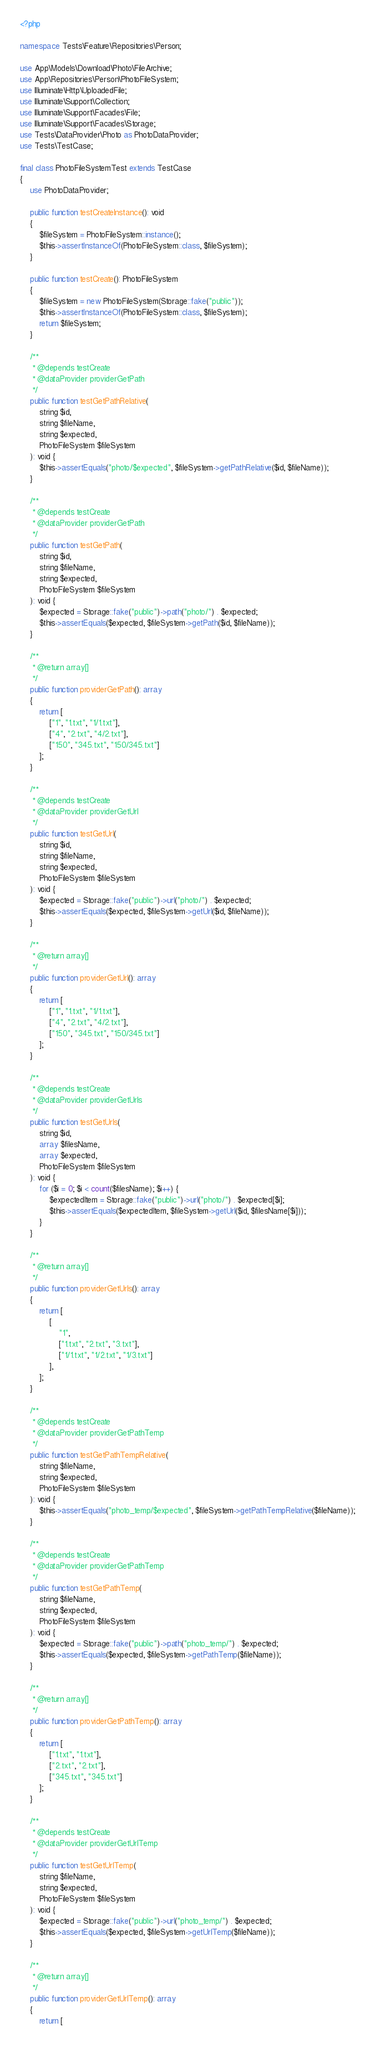<code> <loc_0><loc_0><loc_500><loc_500><_PHP_><?php

namespace Tests\Feature\Repositories\Person;

use App\Models\Download\Photo\FileArchive;
use App\Repositories\Person\PhotoFileSystem;
use Illuminate\Http\UploadedFile;
use Illuminate\Support\Collection;
use Illuminate\Support\Facades\File;
use Illuminate\Support\Facades\Storage;
use Tests\DataProvider\Photo as PhotoDataProvider;
use Tests\TestCase;

final class PhotoFileSystemTest extends TestCase
{
    use PhotoDataProvider;

    public function testCreateInstance(): void
    {
        $fileSystem = PhotoFileSystem::instance();
        $this->assertInstanceOf(PhotoFileSystem::class, $fileSystem);
    }

    public function testCreate(): PhotoFileSystem
    {
        $fileSystem = new PhotoFileSystem(Storage::fake("public"));
        $this->assertInstanceOf(PhotoFileSystem::class, $fileSystem);
        return $fileSystem;
    }

    /**
     * @depends testCreate
     * @dataProvider providerGetPath
     */
    public function testGetPathRelative(
        string $id,
        string $fileName,
        string $expected,
        PhotoFileSystem $fileSystem
    ): void {
        $this->assertEquals("photo/$expected", $fileSystem->getPathRelative($id, $fileName));
    }

    /**
     * @depends testCreate
     * @dataProvider providerGetPath
     */
    public function testGetPath(
        string $id,
        string $fileName,
        string $expected,
        PhotoFileSystem $fileSystem
    ): void {
        $expected = Storage::fake("public")->path("photo/") . $expected;
        $this->assertEquals($expected, $fileSystem->getPath($id, $fileName));
    }

    /**
     * @return array[]
     */
    public function providerGetPath(): array
    {
        return [
            ["1", "1.txt", "1/1.txt"],
            ["4", "2.txt", "4/2.txt"],
            ["150", "345.txt", "150/345.txt"]
        ];
    }

    /**
     * @depends testCreate
     * @dataProvider providerGetUrl
     */
    public function testGetUrl(
        string $id,
        string $fileName,
        string $expected,
        PhotoFileSystem $fileSystem
    ): void {
        $expected = Storage::fake("public")->url("photo/") . $expected;
        $this->assertEquals($expected, $fileSystem->getUrl($id, $fileName));
    }

    /**
     * @return array[]
     */
    public function providerGetUrl(): array
    {
        return [
            ["1", "1.txt", "1/1.txt"],
            ["4", "2.txt", "4/2.txt"],
            ["150", "345.txt", "150/345.txt"]
        ];
    }

    /**
     * @depends testCreate
     * @dataProvider providerGetUrls
     */
    public function testGetUrls(
        string $id,
        array $filesName,
        array $expected,
        PhotoFileSystem $fileSystem
    ): void {
        for ($i = 0; $i < count($filesName); $i++) {
            $expectedItem = Storage::fake("public")->url("photo/") . $expected[$i];
            $this->assertEquals($expectedItem, $fileSystem->getUrl($id, $filesName[$i]));
        }
    }

    /**
     * @return array[]
     */
    public function providerGetUrls(): array
    {
        return [
            [
                "1",
                ["1.txt", "2.txt", "3.txt"],
                ["1/1.txt", "1/2.txt", "1/3.txt"]
            ],
        ];
    }

    /**
     * @depends testCreate
     * @dataProvider providerGetPathTemp
     */
    public function testGetPathTempRelative(
        string $fileName,
        string $expected,
        PhotoFileSystem $fileSystem
    ): void {
        $this->assertEquals("photo_temp/$expected", $fileSystem->getPathTempRelative($fileName));
    }

    /**
     * @depends testCreate
     * @dataProvider providerGetPathTemp
     */
    public function testGetPathTemp(
        string $fileName,
        string $expected,
        PhotoFileSystem $fileSystem
    ): void {
        $expected = Storage::fake("public")->path("photo_temp/") . $expected;
        $this->assertEquals($expected, $fileSystem->getPathTemp($fileName));
    }

    /**
     * @return array[]
     */
    public function providerGetPathTemp(): array
    {
        return [
            ["1.txt", "1.txt"],
            ["2.txt", "2.txt"],
            ["345.txt", "345.txt"]
        ];
    }

    /**
     * @depends testCreate
     * @dataProvider providerGetUrlTemp
     */
    public function testGetUrlTemp(
        string $fileName,
        string $expected,
        PhotoFileSystem $fileSystem
    ): void {
        $expected = Storage::fake("public")->url("photo_temp/") . $expected;
        $this->assertEquals($expected, $fileSystem->getUrlTemp($fileName));
    }

    /**
     * @return array[]
     */
    public function providerGetUrlTemp(): array
    {
        return [</code> 